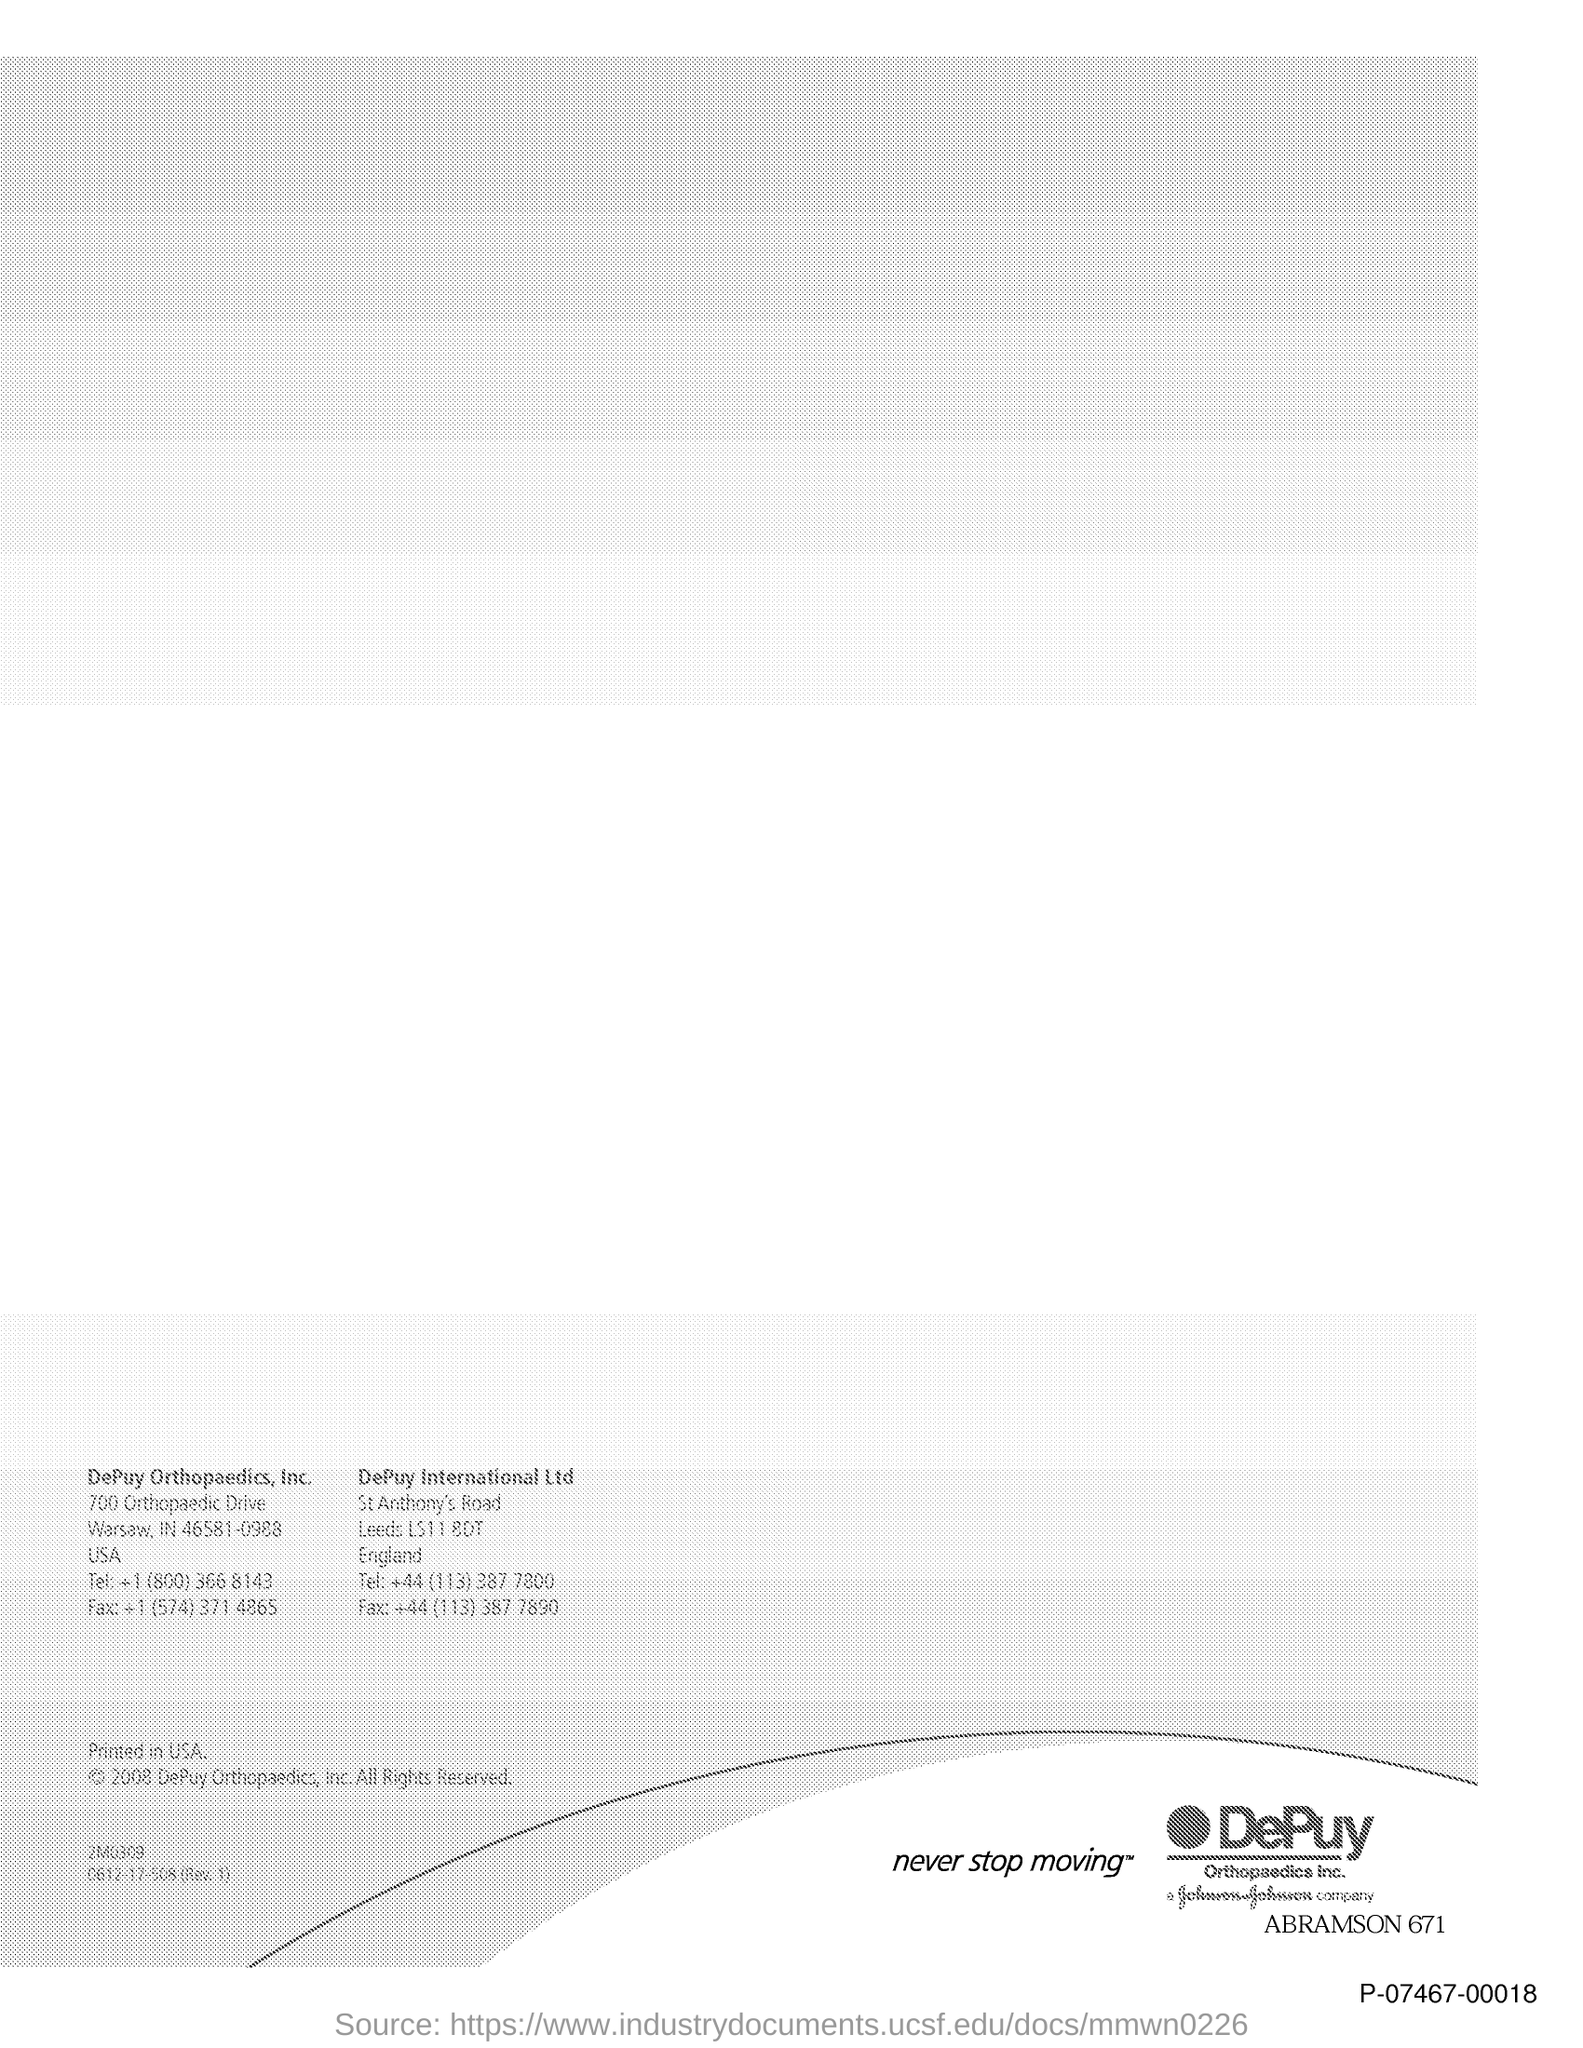Point out several critical features in this image. The telephone number for DePuy International Ltd is +44 (113) 387 7800. The fax number for DePuy International Ltd is +44 (113) 387 7890. 